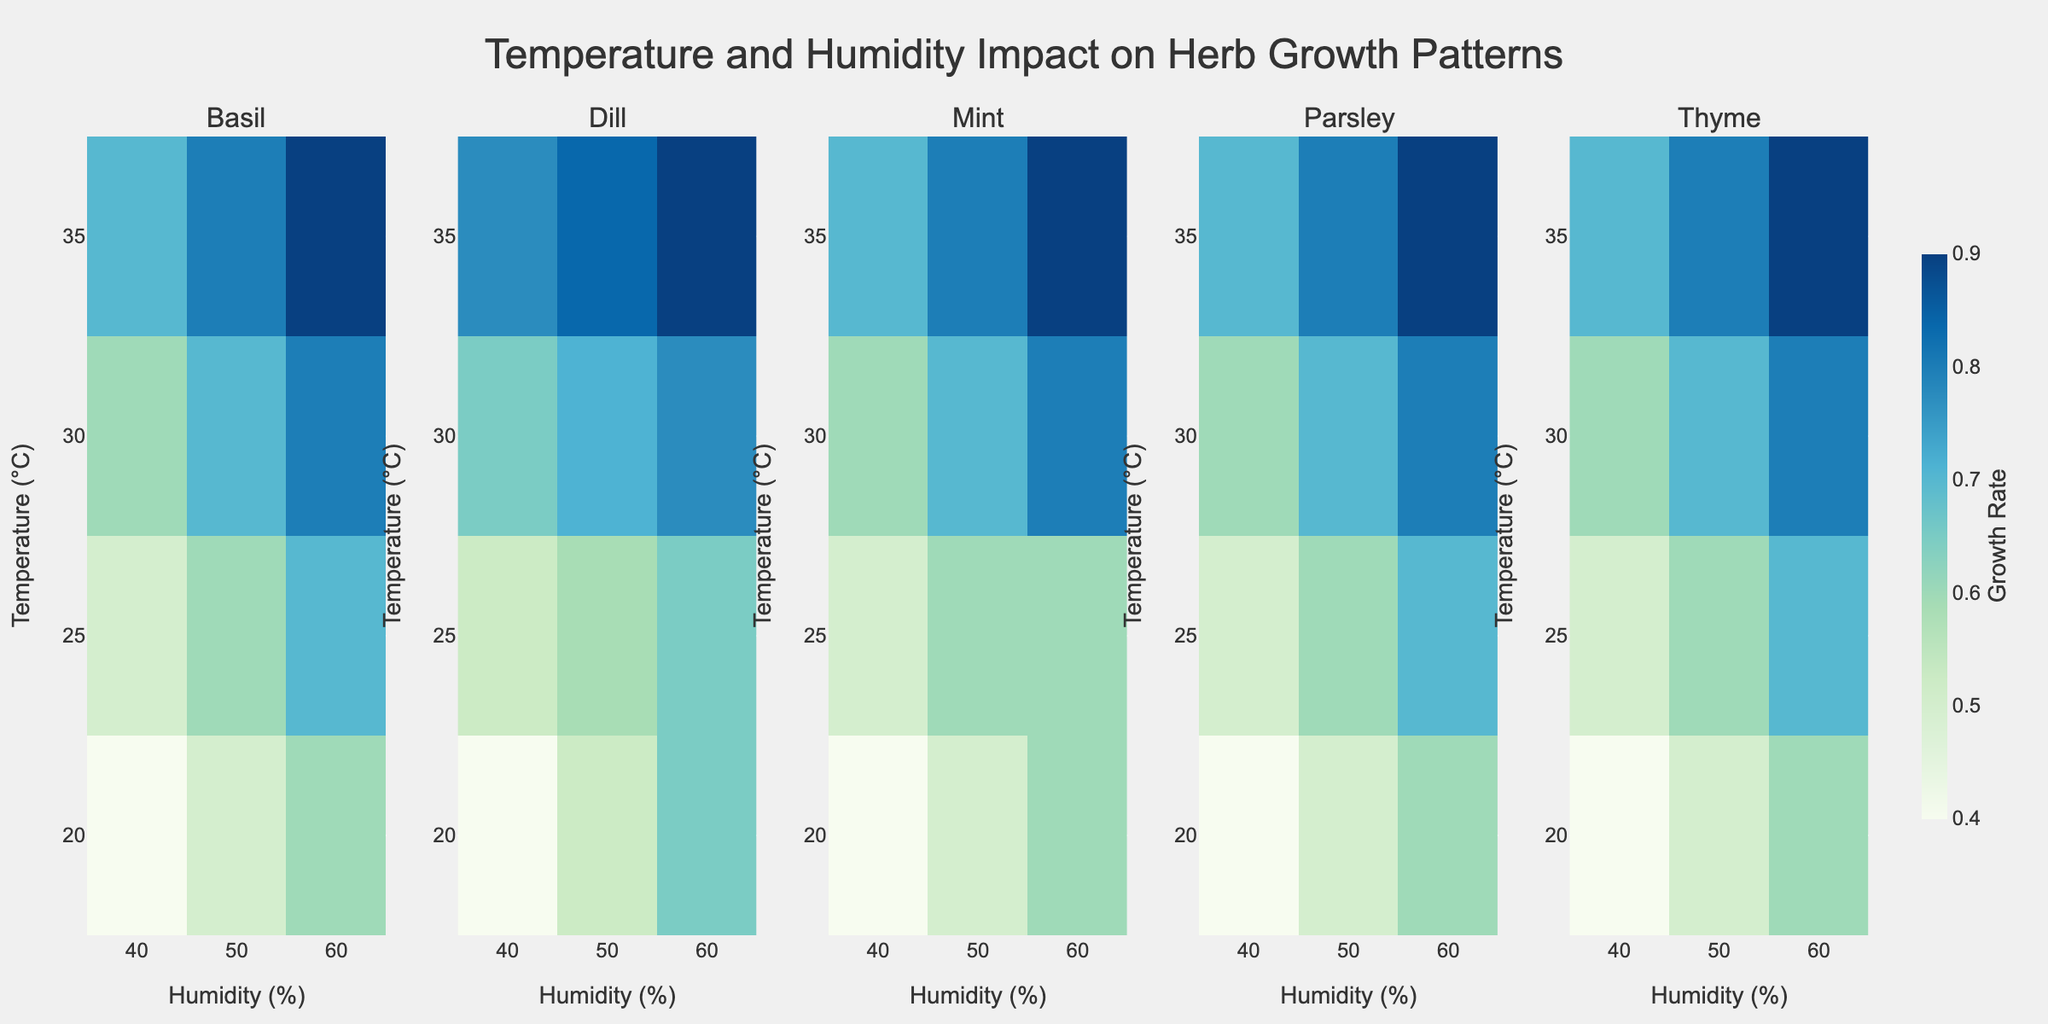What is the title of the figure? The title is located at the top center of the figure.
Answer: Temperature and Humidity Impact on Herb Growth Patterns What are the x-axis and y-axis labels? The x-axis label is found at the bottom of each subplot, and the y-axis label is found on the left side of the figure.
Answer: Humidity (%), Temperature (°C) How many herbs are analyzed in the figure? The figure contains five subplots, one for each herb, indicating that five herbs are analyzed.
Answer: 5 What is the highest growth rate observed for Basil, and at what temperature and humidity does it occur? Look at the subplot for Basil and find the highest value. It's 1.1 at 35°C and 60% humidity.
Answer: 1.1, 35°C, 60% Which herb shows the highest growth rate overall, and what is the rate? Look for the highest value across all subplots. Mint has the highest growth rate of 1.3.
Answer: Mint, 1.3 Between 25°C and 50% Humidity, which herb has the lowest growth rate? Check the values at 25°C and 50% humidity for all herbs. Thyme has the lowest growth rate of 0.6.
Answer: Thyme What is the average growth rate for Parsley at 30°C across all humidity levels? Add Parsley's growth rates at 30°C for humidity 40%, 50%, and 60%, then divide by 3. (0.7 + 0.8 + 0.9) / 3 = 0.8
Answer: 0.8 Which two herbs have equal growth rates at 25°C and 50% humidity? Check the growth rates at 25°C and 50% humidity for all herbs. Dill and Mint both have a growth rate of 0.85.
Answer: Dill, Mint Which herb shows the most significant increase in growth rate from 20°C to 35°C at 60% humidity? Find the differences in growth rates at 60% humidity between 20°C and 35°C for all herbs. Basil increases from 0.8 to 1.1, a difference of 0.3, the most significant increase.
Answer: Basil 